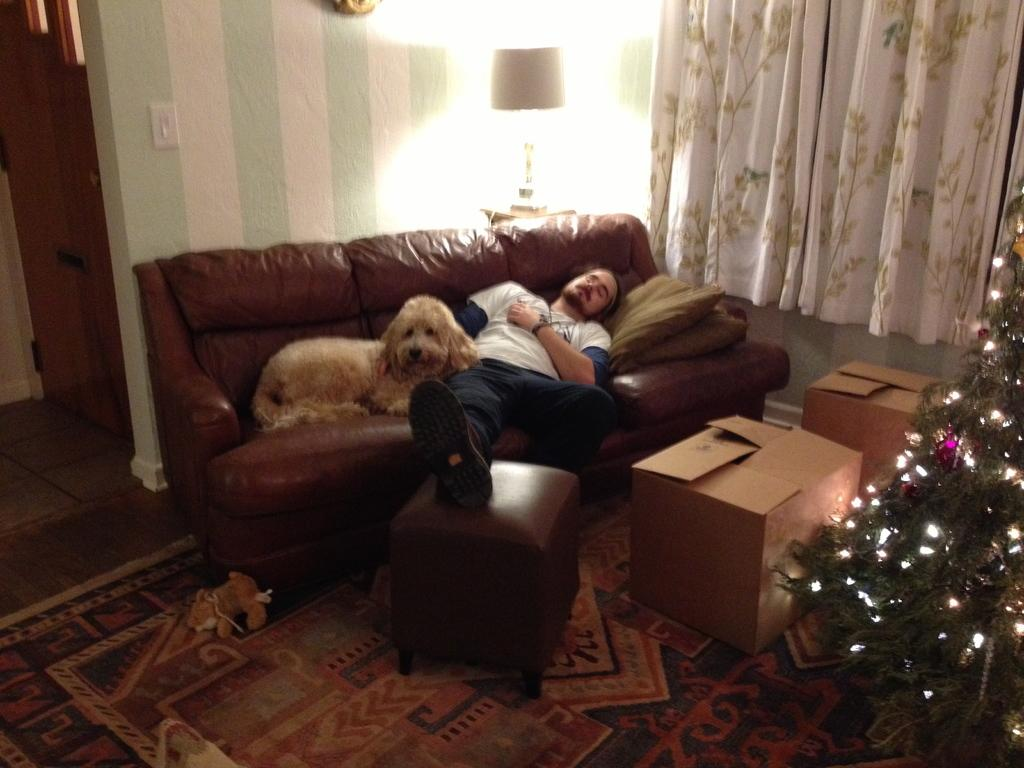What is the person in the image doing? There is a person lying on the couch in the image. What is the dog doing in the image? There is a dog sitting on the couch in the image. What can be seen on the right side of the image? There is a Christmas tree and a white-colored curtain on the right side of the image. What type of plastic is covering the Christmas tree in the image? There is no plastic covering the Christmas tree in the image; it is not mentioned in the provided facts. Can you see any insects crawling on the curtain in the image? There is no mention of insects in the image, so it cannot be determined if any are present. 